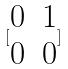<formula> <loc_0><loc_0><loc_500><loc_500>[ \begin{matrix} 0 & 1 \\ 0 & 0 \end{matrix} ]</formula> 